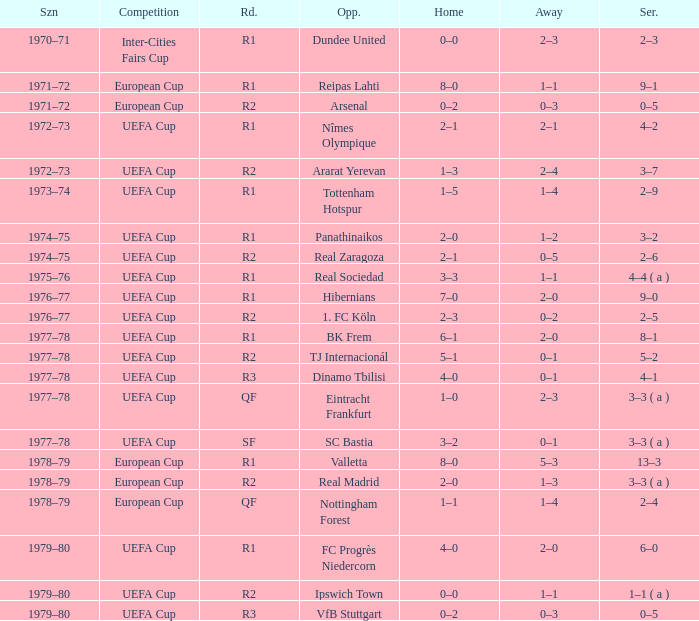Which Round has a Competition of uefa cup, and a Series of 5–2? R2. 